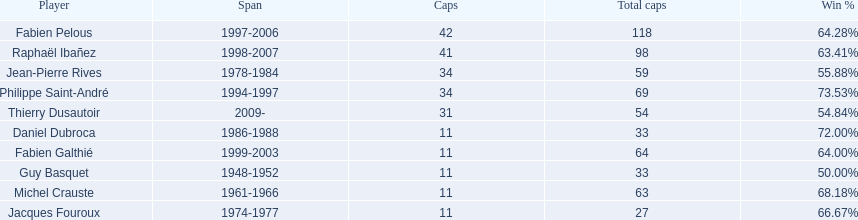How many players possess time spans over three years? 6. 